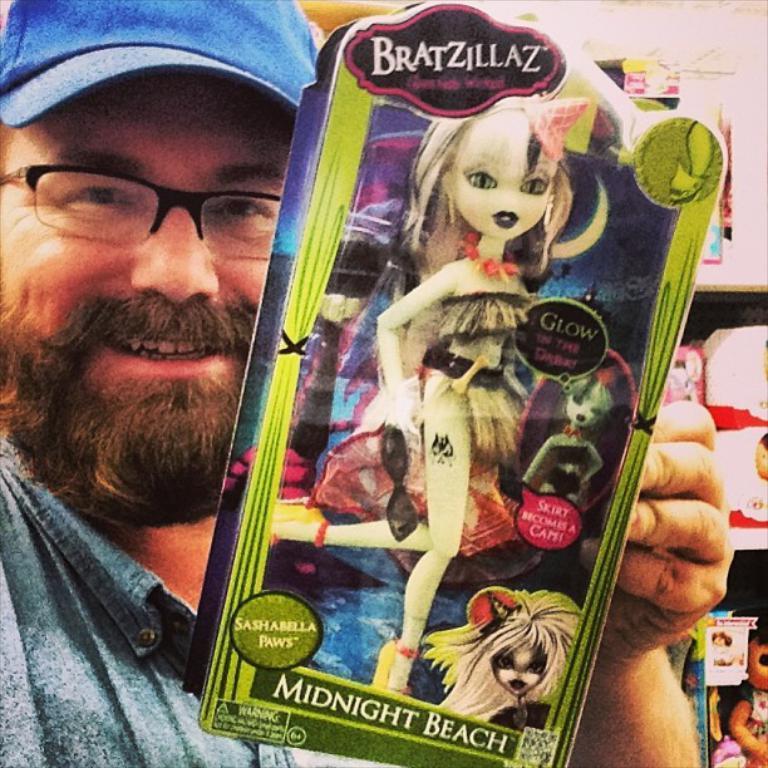Please provide a concise description of this image. In this image we can see a man is holding a toy packet in his hand. In the background there are packets and toys on the racks. 